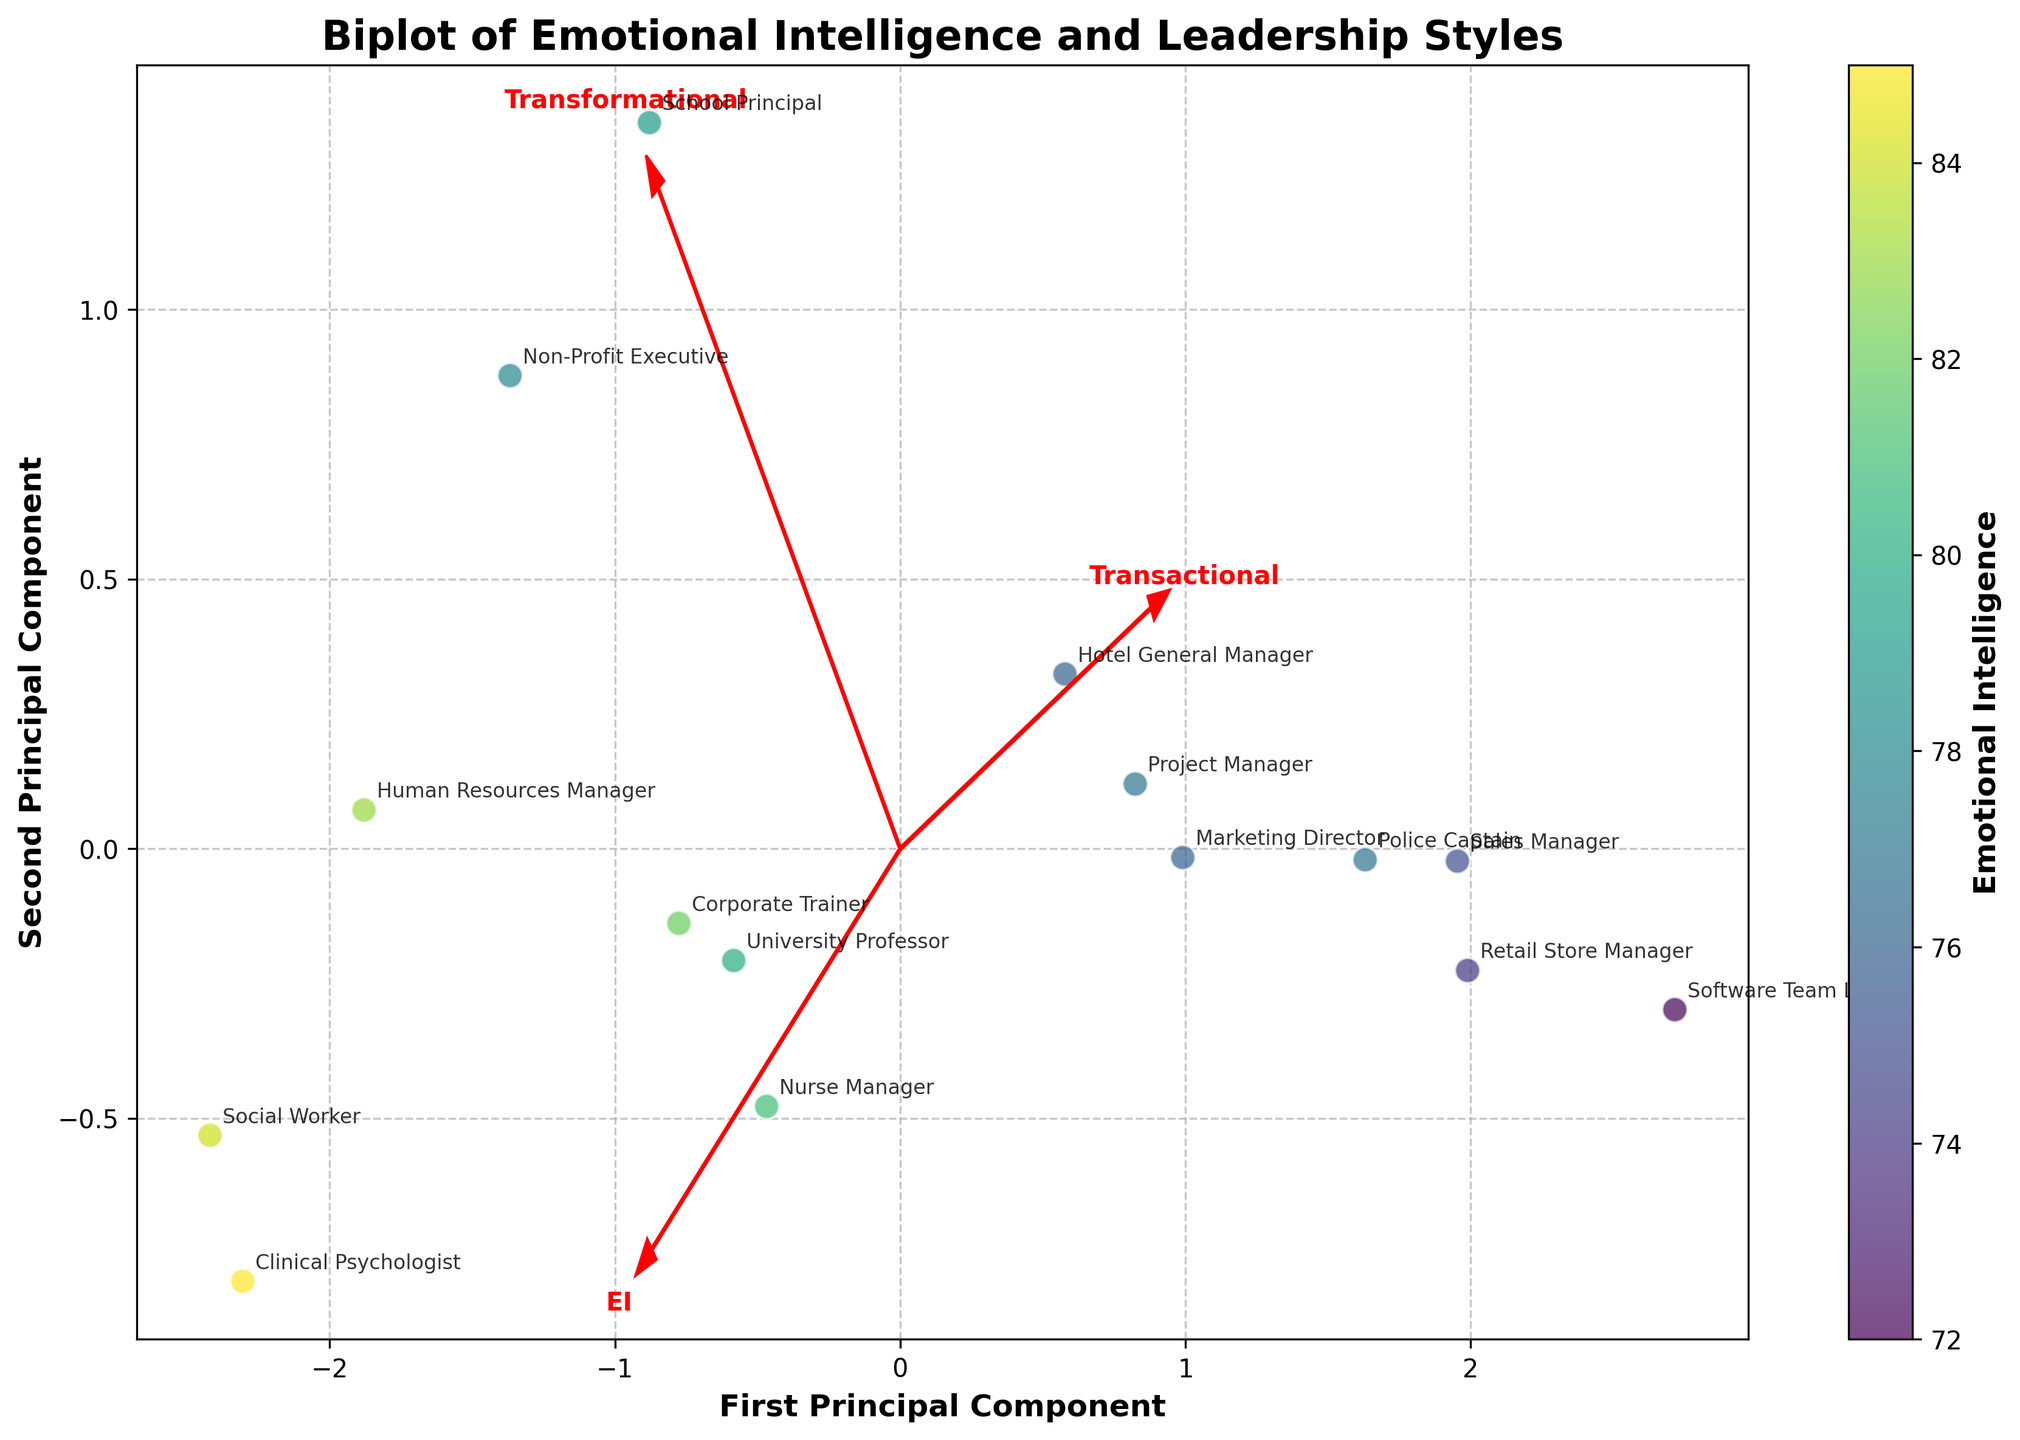What is the title of the plot? The title is prominently displayed at the top of the plot.
Answer: Biplot of Emotional Intelligence and Leadership Styles How many professions are represented in the plot? There are distinct data points with annotated labels for each profession. Count the labels.
Answer: 15 Which profession has the highest value of emotional intelligence and where is it located in the plot? Find the profession with the highest emotional intelligence value and locate its corresponding data point on the plot.
Answer: Clinical Psychologist, top-right area What color represents higher emotional intelligence on the plot? Identify the color gradient on the colorbar. Higher values of emotional intelligence should correspond to a specific color range.
Answer: Yellow Which profession is closest to the arrow representing the 'Transformational' leadership style? Look at the arrow labeled 'Transformational' and find the nearest profession label to this feature vector.
Answer: School Principal Which two professions have the most similar positions in the plot? Inspect the plot to find two data points that are very close to each other, indicating similar relationships between the components analyzed.
Answer: Nurse Manager and Hotel General Manager Which axis explains more variance, the first principal component or the second principal component? This can be inferred from the plot configuration and the typical variance distribution in PCA biplots. Usually, the first principal component explains more variance.
Answer: First principal component Which direction is the feature vector for 'Transactional' leadership pointing relative to the origin? Observe the 'Transactional' leadership arrow and describe its orientation from the origin.
Answer: Bottom-right How does the plot show the relationship between professions and leadership styles? Analyze the placement of data points and the orientation of arrows to describe how leadership styles affect the positioning.
Answer: The plot illustrates the relationship by showing how each profession is influenced by various leadership styles through the direction and length of feature vectors Which professions have lower transformational leadership scores based on their position on the plot? Identify professions that are located further from the arrow representing transformational leadership towards the plot's opposite end.
Answer: Software Team Lead, Police Captain 